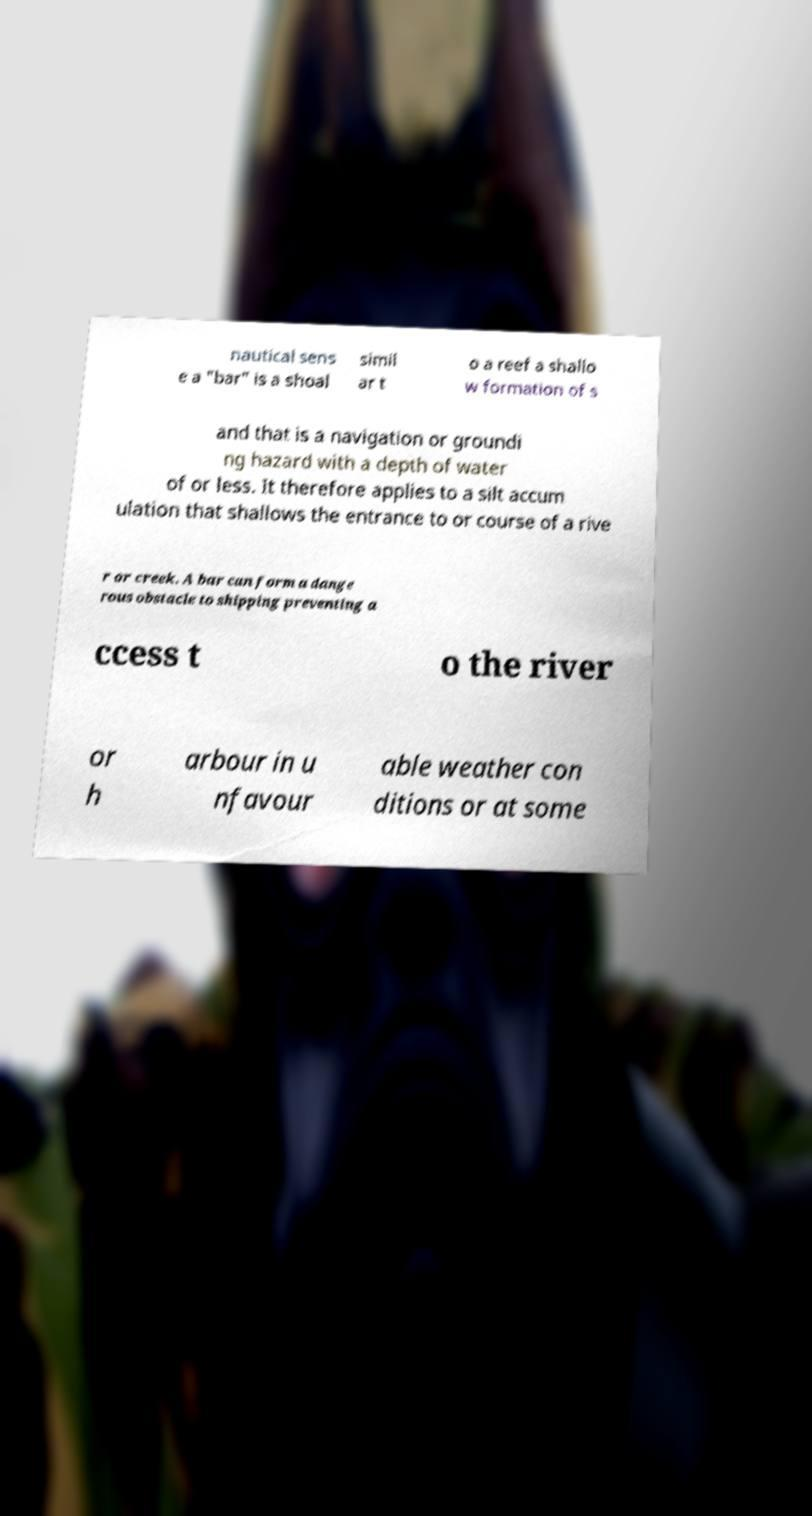Please identify and transcribe the text found in this image. nautical sens e a "bar" is a shoal simil ar t o a reef a shallo w formation of s and that is a navigation or groundi ng hazard with a depth of water of or less. It therefore applies to a silt accum ulation that shallows the entrance to or course of a rive r or creek. A bar can form a dange rous obstacle to shipping preventing a ccess t o the river or h arbour in u nfavour able weather con ditions or at some 